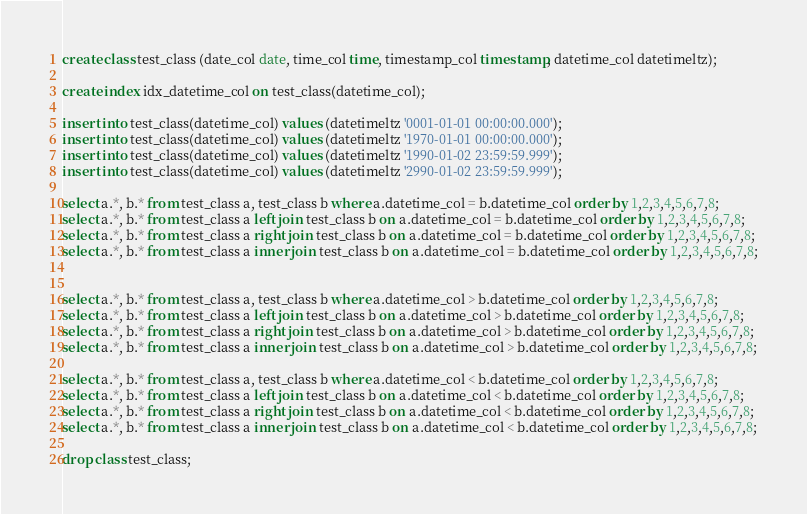<code> <loc_0><loc_0><loc_500><loc_500><_SQL_>create class test_class (date_col date, time_col time, timestamp_col timestamp, datetime_col datetimeltz);

create index idx_datetime_col on test_class(datetime_col);

insert into test_class(datetime_col) values (datetimeltz '0001-01-01 00:00:00.000');
insert into test_class(datetime_col) values (datetimeltz '1970-01-01 00:00:00.000');
insert into test_class(datetime_col) values (datetimeltz '1990-01-02 23:59:59.999');
insert into test_class(datetime_col) values (datetimeltz '2990-01-02 23:59:59.999');

select a.*, b.* from test_class a, test_class b where a.datetime_col = b.datetime_col order by 1,2,3,4,5,6,7,8;
select a.*, b.* from test_class a left join test_class b on a.datetime_col = b.datetime_col order by 1,2,3,4,5,6,7,8;
select a.*, b.* from test_class a right join test_class b on a.datetime_col = b.datetime_col order by 1,2,3,4,5,6,7,8;
select a.*, b.* from test_class a inner join test_class b on a.datetime_col = b.datetime_col order by 1,2,3,4,5,6,7,8;


select a.*, b.* from test_class a, test_class b where a.datetime_col > b.datetime_col order by 1,2,3,4,5,6,7,8;
select a.*, b.* from test_class a left join test_class b on a.datetime_col > b.datetime_col order by 1,2,3,4,5,6,7,8;
select a.*, b.* from test_class a right join test_class b on a.datetime_col > b.datetime_col order by 1,2,3,4,5,6,7,8;
select a.*, b.* from test_class a inner join test_class b on a.datetime_col > b.datetime_col order by 1,2,3,4,5,6,7,8;

select a.*, b.* from test_class a, test_class b where a.datetime_col < b.datetime_col order by 1,2,3,4,5,6,7,8;
select a.*, b.* from test_class a left join test_class b on a.datetime_col < b.datetime_col order by 1,2,3,4,5,6,7,8;
select a.*, b.* from test_class a right join test_class b on a.datetime_col < b.datetime_col order by 1,2,3,4,5,6,7,8;
select a.*, b.* from test_class a inner join test_class b on a.datetime_col < b.datetime_col order by 1,2,3,4,5,6,7,8;

drop class test_class;</code> 